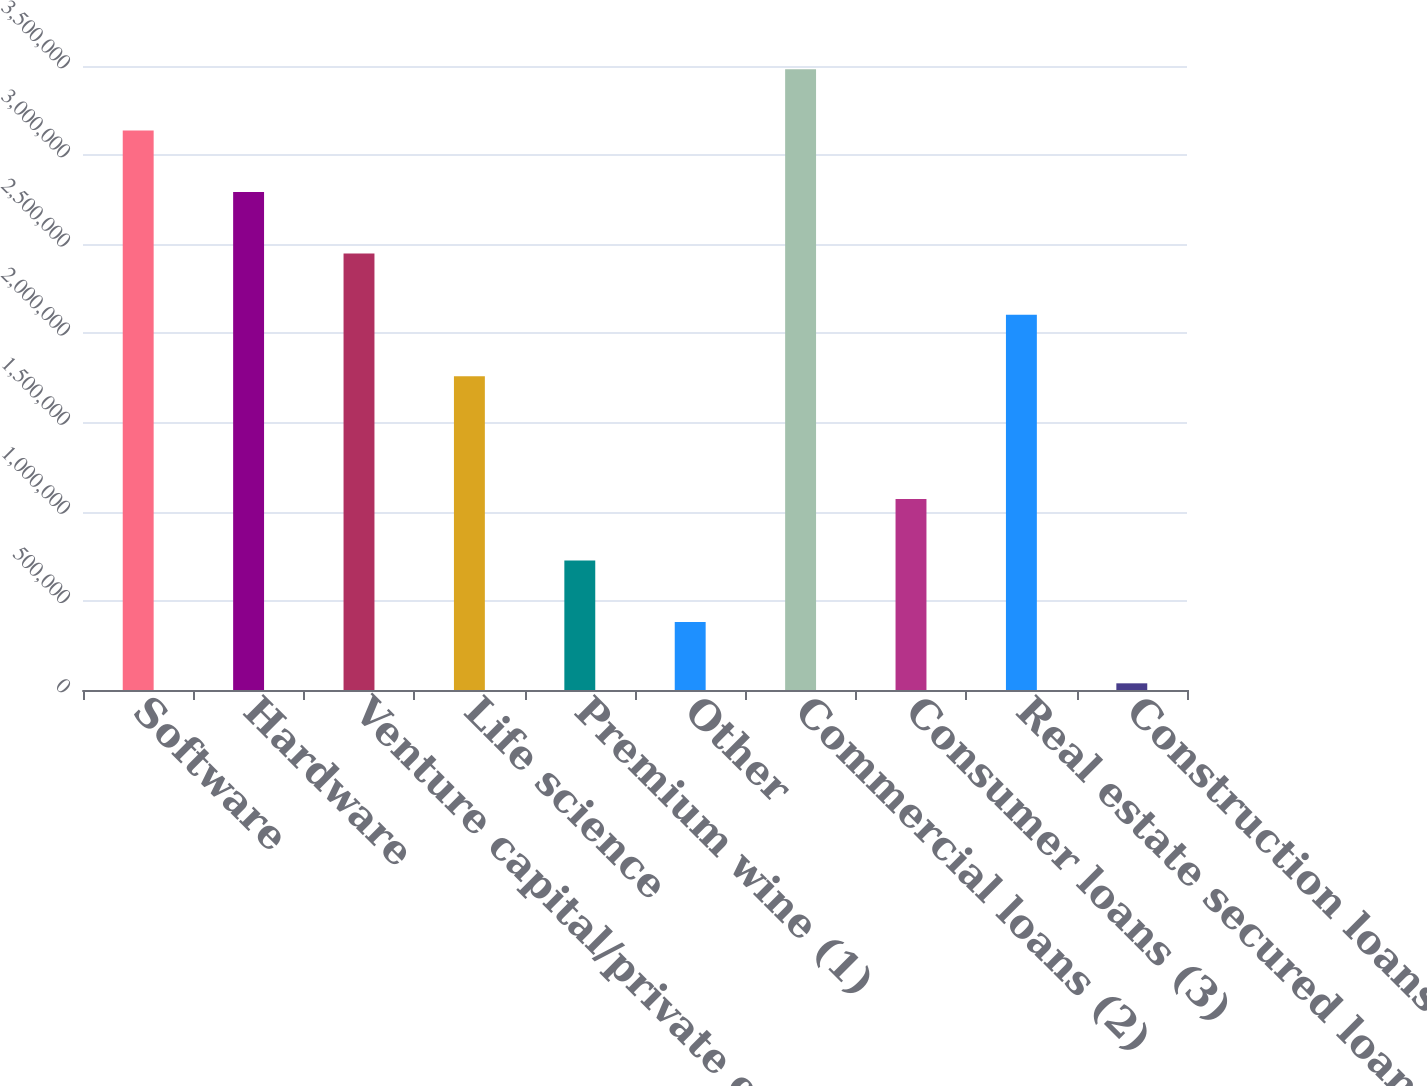Convert chart to OTSL. <chart><loc_0><loc_0><loc_500><loc_500><bar_chart><fcel>Software<fcel>Hardware<fcel>Venture capital/private equity<fcel>Life science<fcel>Premium wine (1)<fcel>Other<fcel>Commercial loans (2)<fcel>Consumer loans (3)<fcel>Real estate secured loans<fcel>Construction loans (4)<nl><fcel>3.13791e+06<fcel>2.79341e+06<fcel>2.44892e+06<fcel>1.75993e+06<fcel>726441<fcel>381946<fcel>3.4824e+06<fcel>1.07094e+06<fcel>2.10442e+06<fcel>37451<nl></chart> 